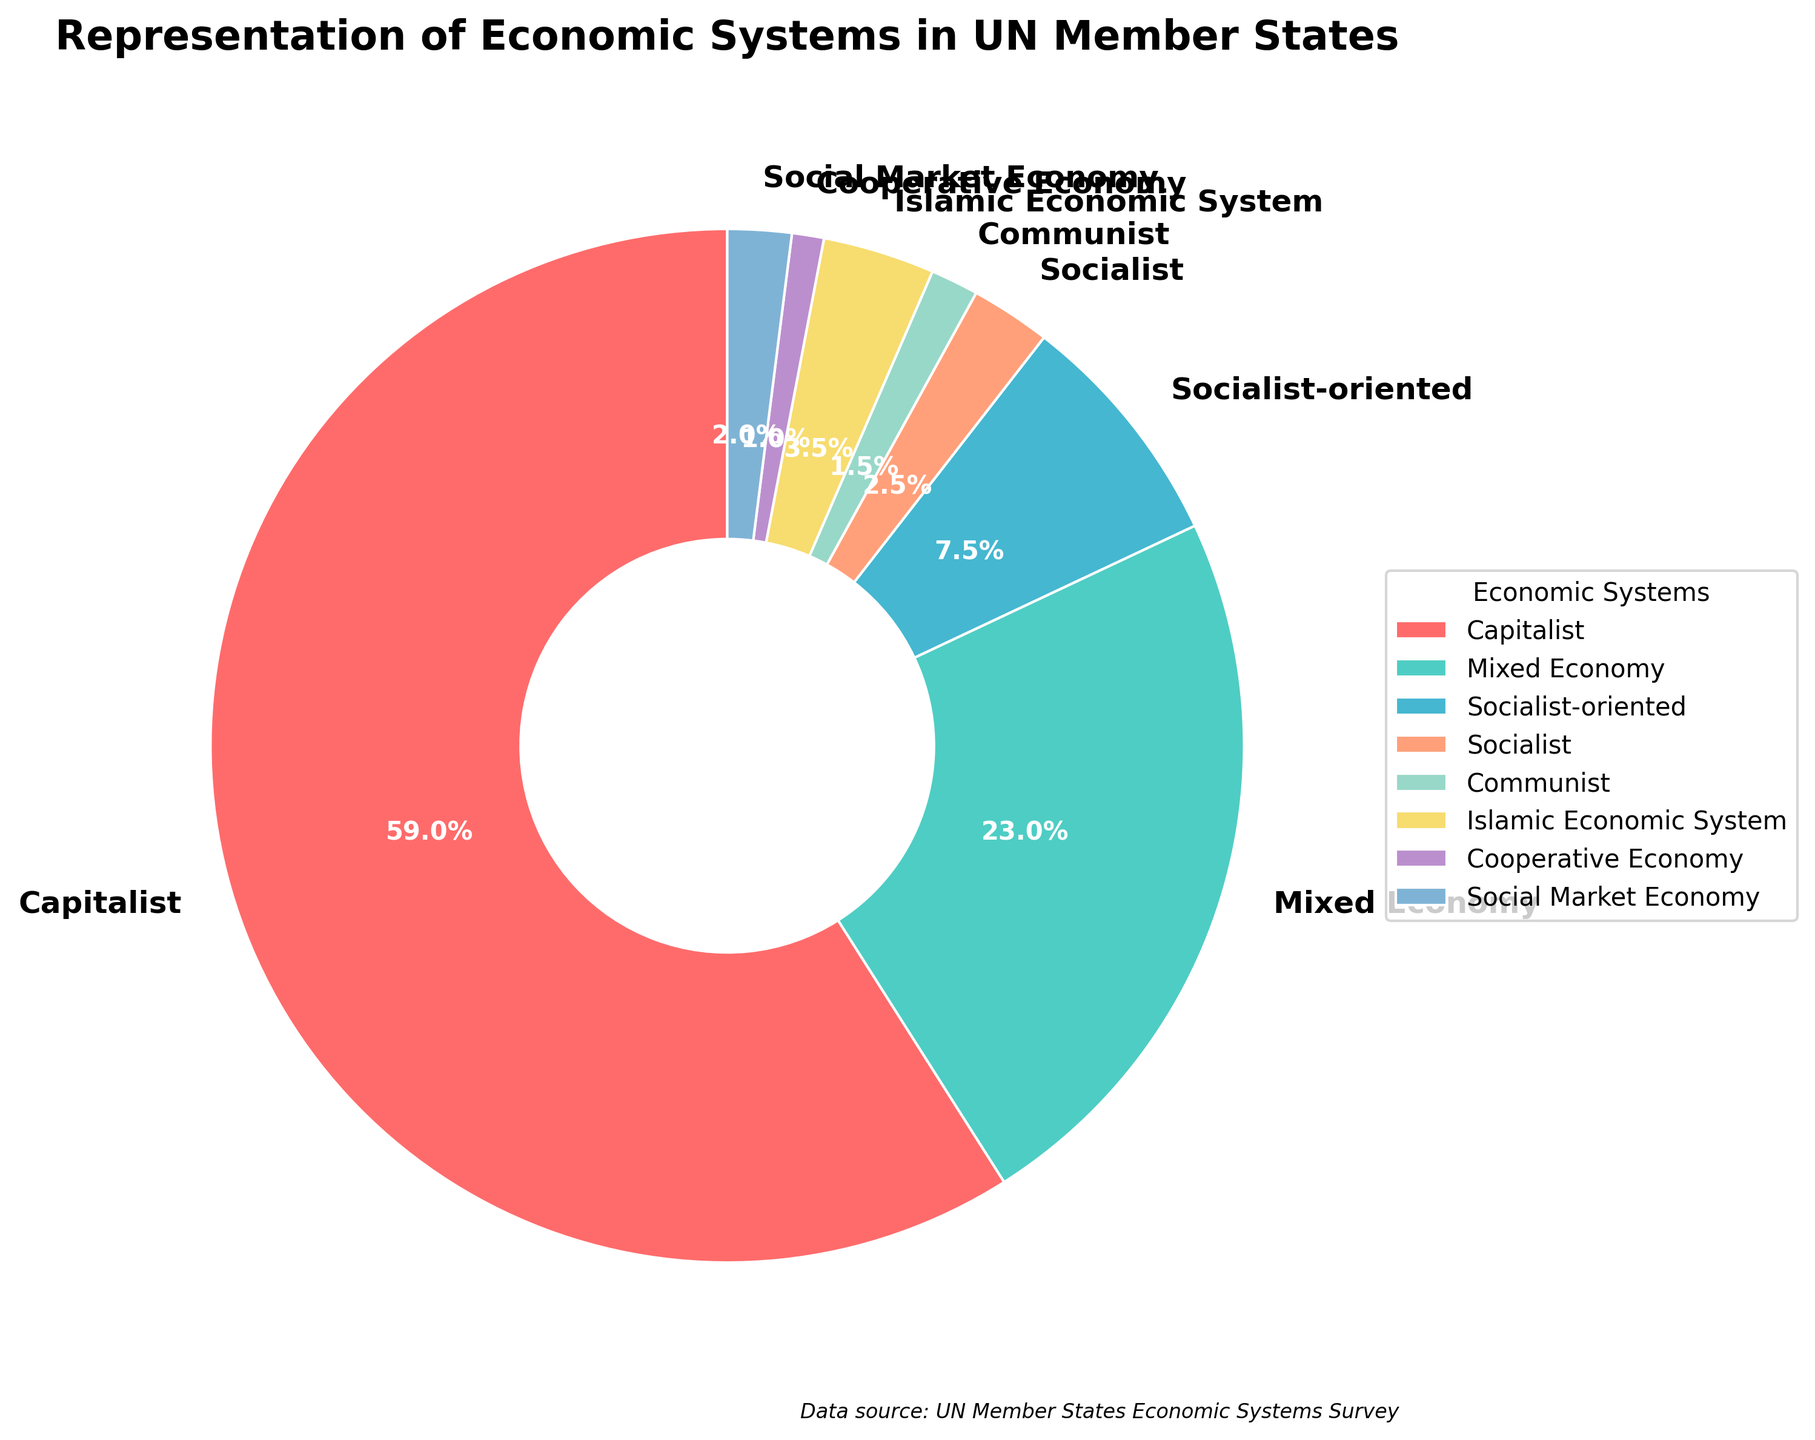What is the percentage representation of capitalist economic systems in UN member states? First, locate the slice labeled "Capitalist" in the pie chart. Observe the percentage indicated on this slice, as the pie chart displays percentages directly for each category.
Answer: 62.1% Which economic system has the smallest representation among UN member states, and what is its percentage? Look for the smallest slice in the pie chart and check its label to identify the economic system. Then, read the percentage displayed within or near this slice.
Answer: Cooperative Economy, 1.1% How many more UN member states follow a capitalist economic system compared to those following a mixed economy? Find the number of UN member states for both the "Capitalist" and "Mixed Economy" categories from the pie chart's legend or labels. Subtract the number of mixed economy states from capitalist states (118 - 46).
Answer: 72 Which two economic systems combined represent just over a quarter (25%) of the total UN member states? Identify the slices with percentages closest to half of 50%, likely around 10-15%, and add their percentages. Look for the two slices whose sum is over 25% (Socialist-oriented: 7.9%, Mixed Economy: 24.2%). Sum these up: 7.9% + 24.2% = 32.1%, which is over a quarter.
Answer: Socialist-oriented and Mixed Economy Among socialist-oriented, socialist, and communist systems, which one has the highest representation, and what is its number? Compare the labels for "Socialist-oriented", "Socialist", and "Communist". Identify which of these has the largest number from the pie chart legend or slice labels.
Answer: Socialist-oriented, 15 How much larger is the representation of mixed economies compared to socialist systems in UN member states? Find the counts for both "Mixed Economy" and "Socialist" from the pie chart legend or slices. Calculate the difference between them (46 - 5).
Answer: 41 What's the total number of UN member states represented by non-capitalist and non-mixed economy systems? Find the number of UN member states for all systems except "Capitalist" and "Mixed Economy". Sum the numbers for Socialist-oriented, Socialist, Communist, Islamic Economic System, Cooperative Economy, and Social Market Economy (15 + 5 + 3 + 7 + 2 + 4).
Answer: 36 What color represents the Islamic Economic System in the pie chart? Look at the pie chart and identify the color given to the slice labeled "Islamic Economic System".
Answer: Yellow How does the representation of Islamic economic systems compare to communist systems in terms of percentage? Find the percentage slices for both "Islamic Economic System" and "Communist" from the pie chart. Compare the two percentages (Islamic Economic System: 3.7%, Communist: 1.6%).
Answer: Islamic Economic System is higher What combined percentage of UN member states follow cooperative, social market, and communist economic systems? Identify and sum the percentages for "Cooperative Economy", "Social Market Economy", and "Communist" systems (1.1% + 2.1% + 1.6%).
Answer: 4.8% 